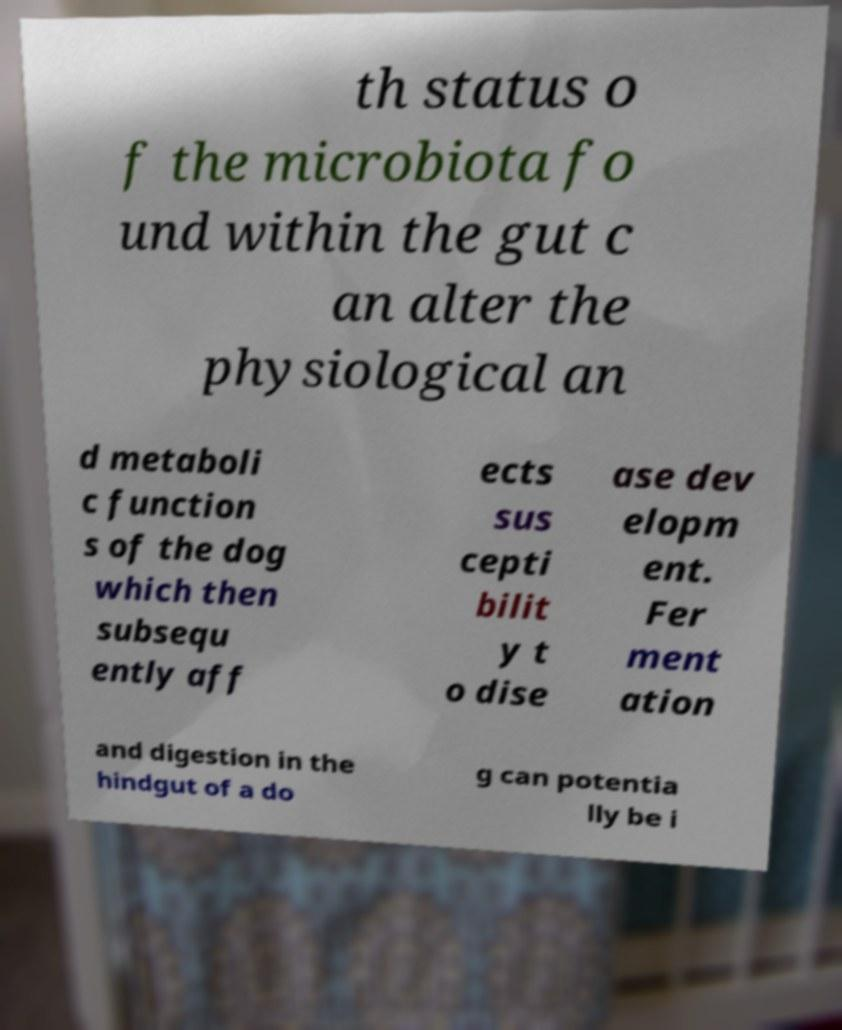Please identify and transcribe the text found in this image. th status o f the microbiota fo und within the gut c an alter the physiological an d metaboli c function s of the dog which then subsequ ently aff ects sus cepti bilit y t o dise ase dev elopm ent. Fer ment ation and digestion in the hindgut of a do g can potentia lly be i 